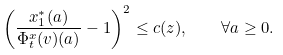Convert formula to latex. <formula><loc_0><loc_0><loc_500><loc_500>\left ( \frac { x ^ { * } _ { 1 } ( a ) } { \Phi _ { t } ^ { x } ( v ) ( a ) } - 1 \right ) ^ { 2 } \leq c ( z ) , \quad \forall a \geq 0 .</formula> 